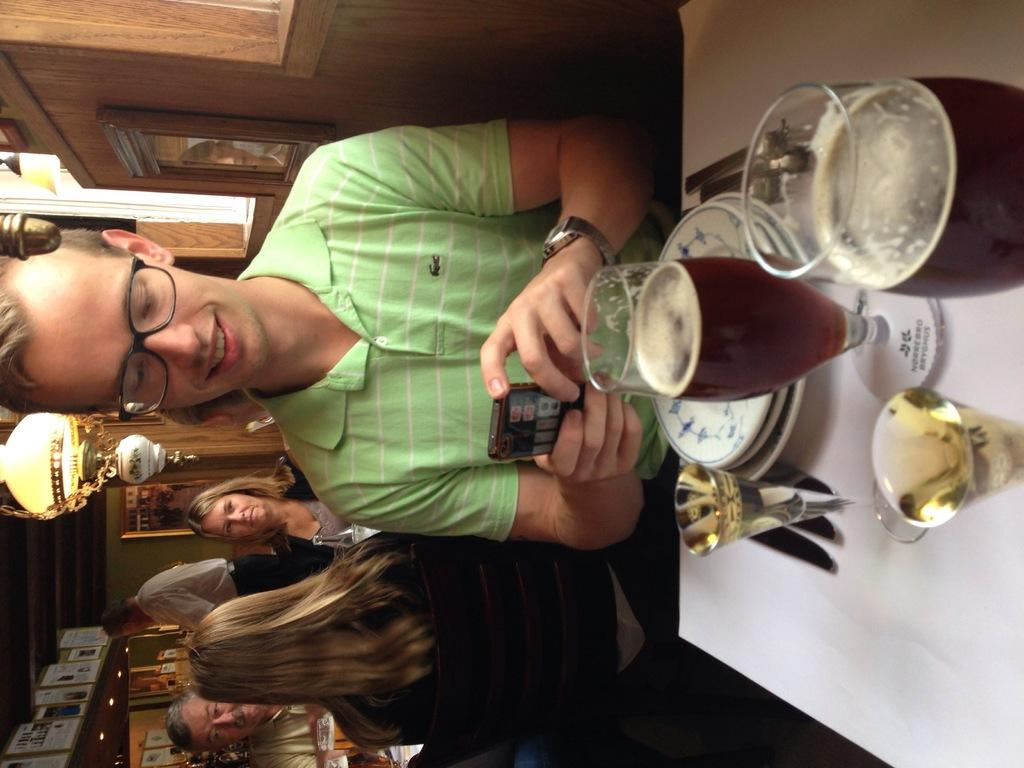What is the person in the image doing? The person is sitting on a chair in the image. What can be seen on the table in the image? There is a wine glass on a table in the image. What is inside the wine glass? The wine glass contains wine. Are there any other people visible in the image? Yes, there are other people standing behind the person sitting on the chair. What type of string is being used to tie the boat at the harbor in the image? There is no harbor or boat present in the image, so there is no string being used to tie anything. 